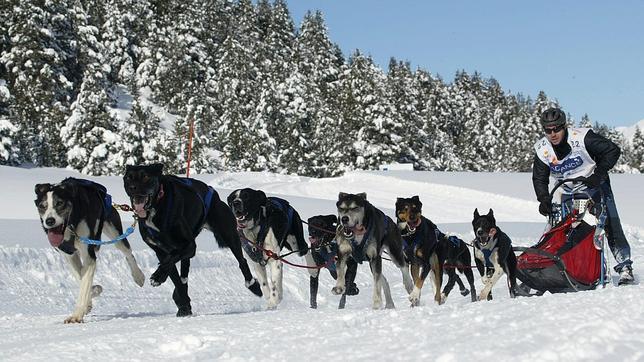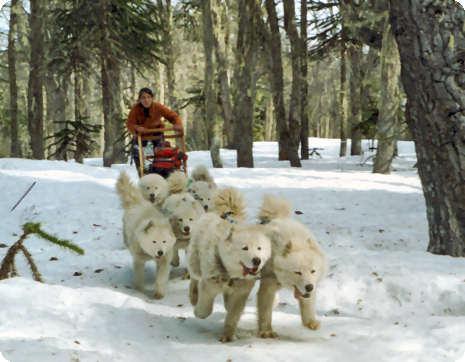The first image is the image on the left, the second image is the image on the right. Evaluate the accuracy of this statement regarding the images: "images are identical". Is it true? Answer yes or no. No. The first image is the image on the left, the second image is the image on the right. Considering the images on both sides, is "A person wearing a blue jacket is driving the sled." valid? Answer yes or no. No. 